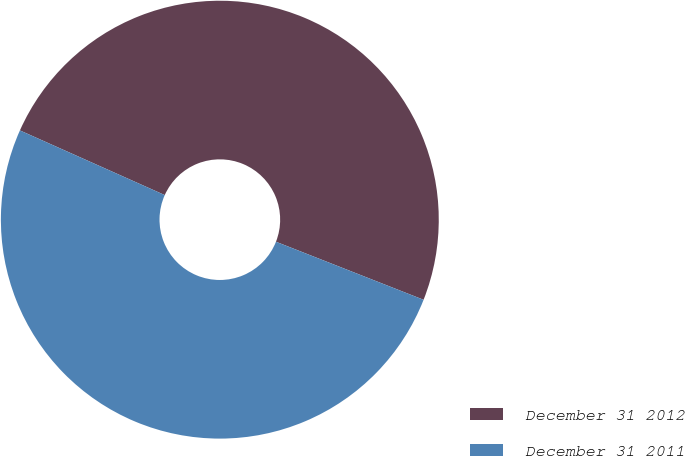Convert chart to OTSL. <chart><loc_0><loc_0><loc_500><loc_500><pie_chart><fcel>December 31 2012<fcel>December 31 2011<nl><fcel>49.28%<fcel>50.72%<nl></chart> 